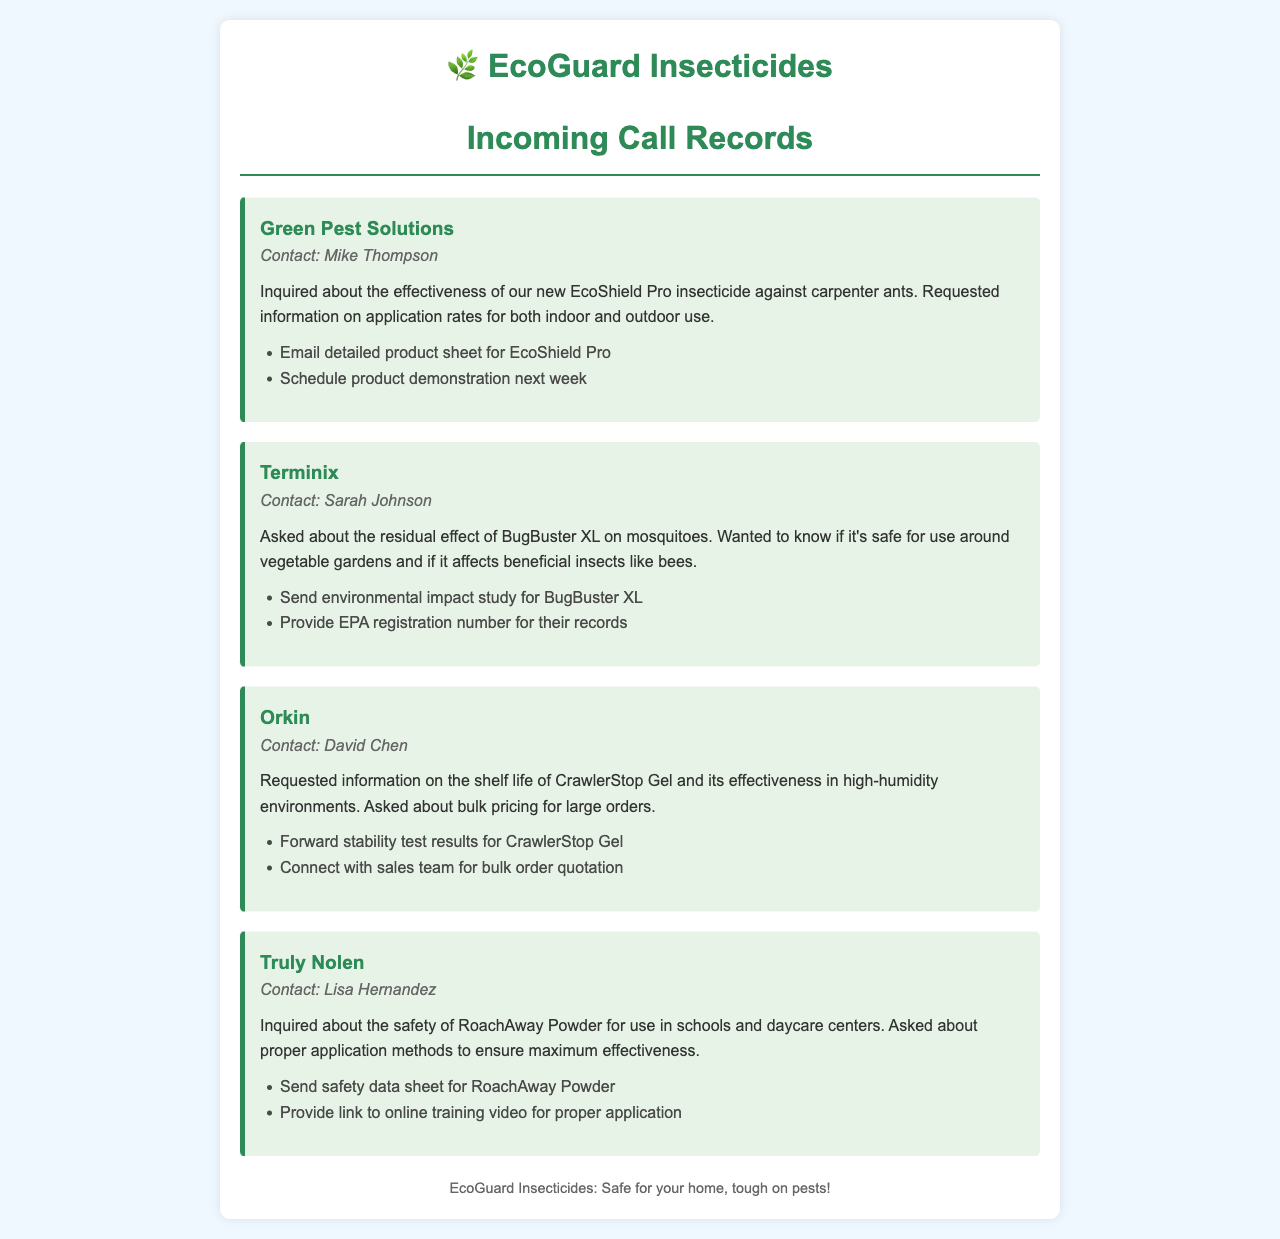what is the name of the first caller? The name of the first caller, as mentioned in the document, is Green Pest Solutions.
Answer: Green Pest Solutions who inquired about BugBuster XL? Sarah Johnson from Terminix inquired about BugBuster XL as noted in the document.
Answer: Sarah Johnson what product was inquired about by Truly Nolen? The document states that Truly Nolen inquired about the safety of RoachAway Powder.
Answer: RoachAway Powder how many action items are associated with Orkin's call? The document lists two action items associated with Orkin's call regarding CrawlerStop Gel.
Answer: 2 what was requested in the call from Green Pest Solutions? They requested information on application rates for EcoShield Pro for both indoor and outdoor use.
Answer: Application rates for EcoShield Pro which product's environmental impact study was requested? The inquiry from Terminix requested the environmental impact study for BugBuster XL.
Answer: BugBuster XL what was the main concern of Truly Nolen's inquiry? The main concern expressed was about the safety of RoachAway Powder for use in schools and daycare centers.
Answer: Safety of RoachAway Powder who should be connected with for bulk order quotation? The document states that the sales team should be connected with for bulk order quotations.
Answer: Sales team 